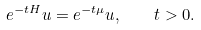<formula> <loc_0><loc_0><loc_500><loc_500>e ^ { - t H } u = e ^ { - t \mu } u , \quad t > 0 .</formula> 